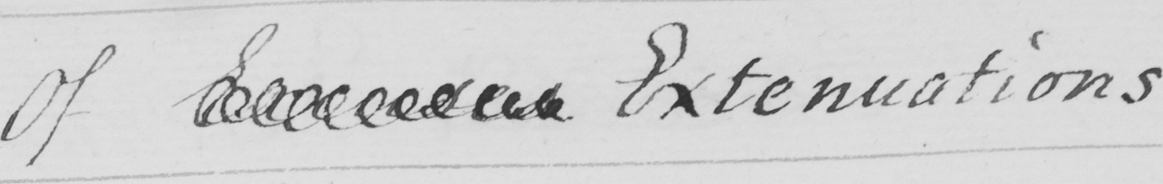Can you read and transcribe this handwriting? Of Excuses Extenuations 